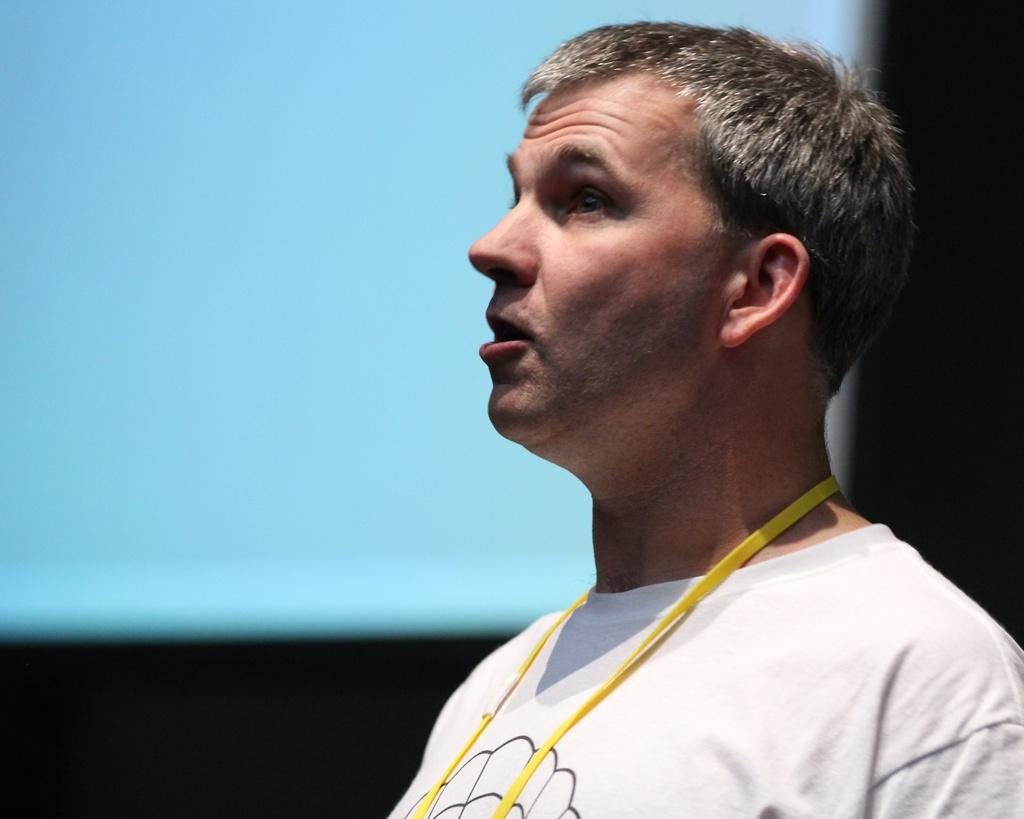What is the position of the man in the image? The man is standing in the bottom right side of the image. What is the man doing in the image? The man is watching something in the image. What is located behind the man in the image? There is a screen behind the man. What book is the man holding in the image? There is no book visible in the image. The man is not holding anything, and the only object mentioned is the screen behind him. 